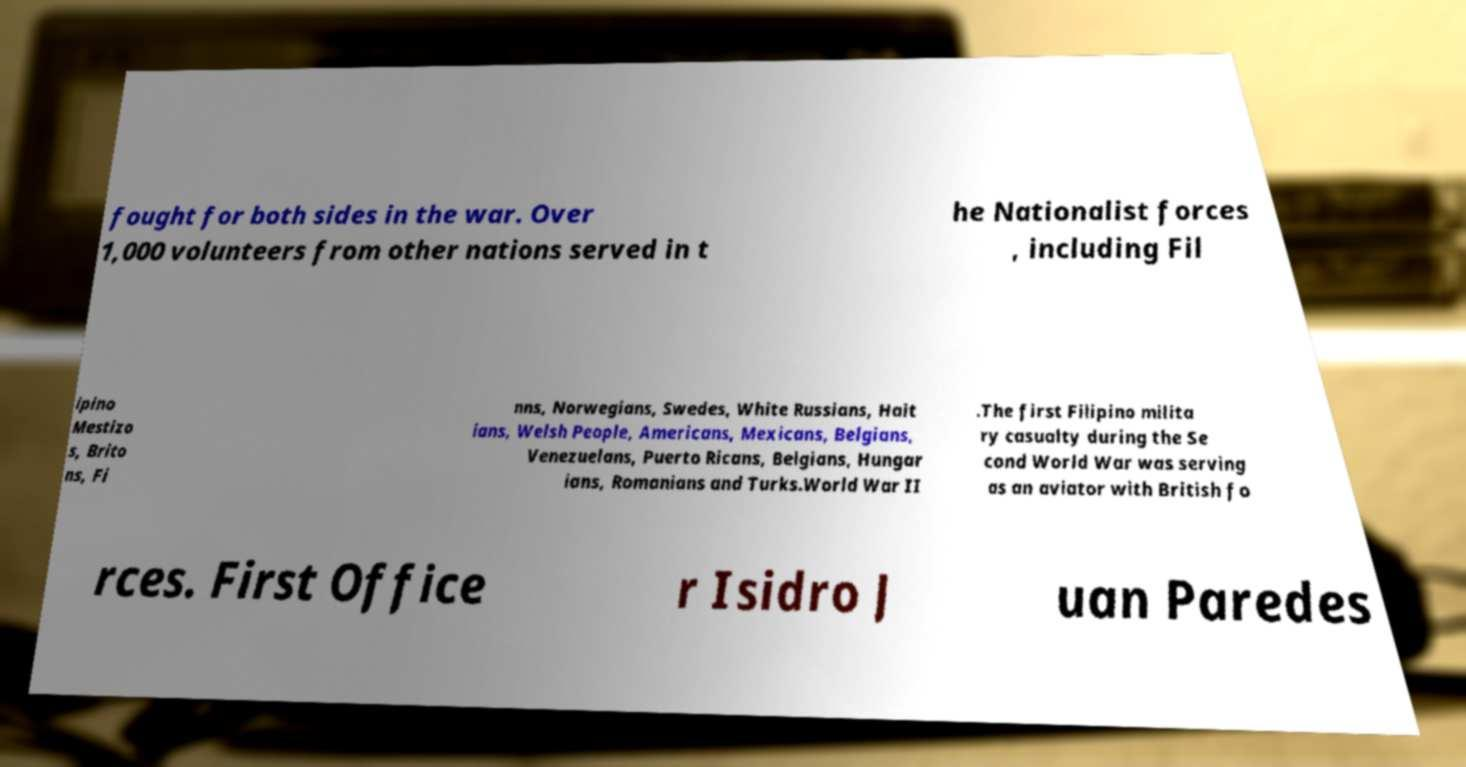For documentation purposes, I need the text within this image transcribed. Could you provide that? fought for both sides in the war. Over 1,000 volunteers from other nations served in t he Nationalist forces , including Fil ipino Mestizo s, Brito ns, Fi nns, Norwegians, Swedes, White Russians, Hait ians, Welsh People, Americans, Mexicans, Belgians, Venezuelans, Puerto Ricans, Belgians, Hungar ians, Romanians and Turks.World War II .The first Filipino milita ry casualty during the Se cond World War was serving as an aviator with British fo rces. First Office r Isidro J uan Paredes 